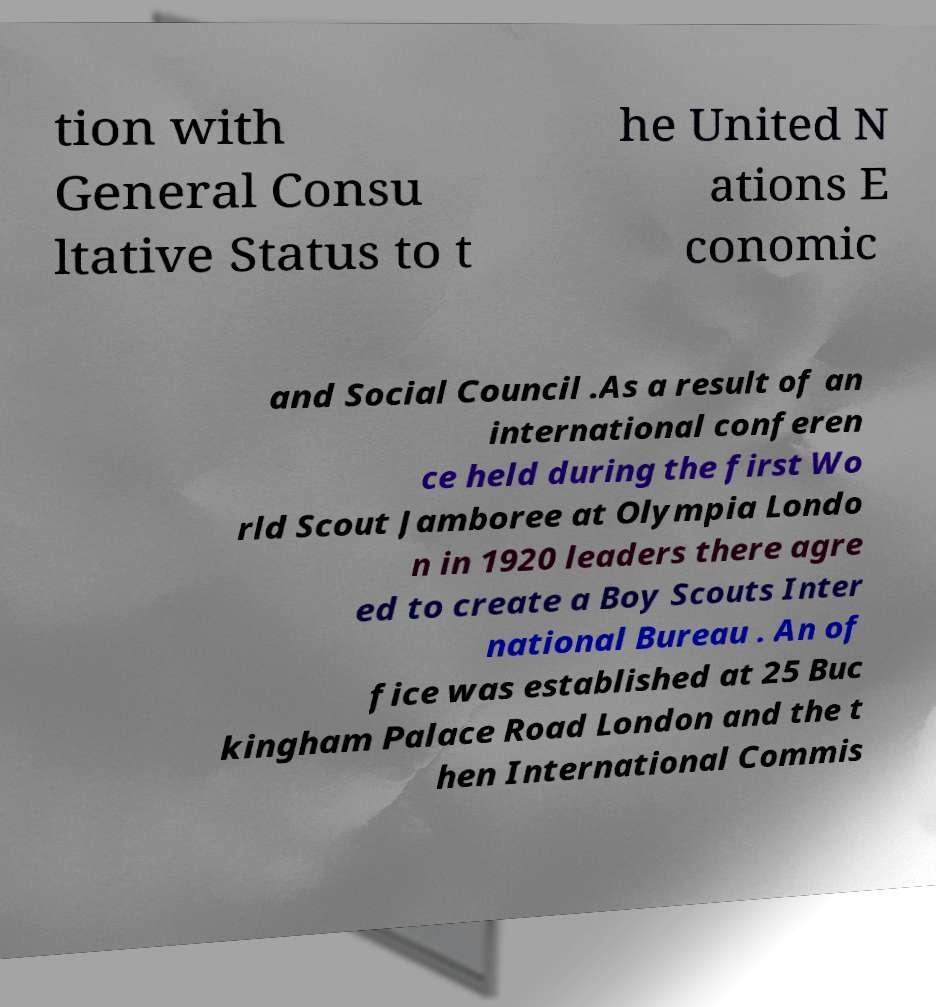Can you read and provide the text displayed in the image?This photo seems to have some interesting text. Can you extract and type it out for me? tion with General Consu ltative Status to t he United N ations E conomic and Social Council .As a result of an international conferen ce held during the first Wo rld Scout Jamboree at Olympia Londo n in 1920 leaders there agre ed to create a Boy Scouts Inter national Bureau . An of fice was established at 25 Buc kingham Palace Road London and the t hen International Commis 